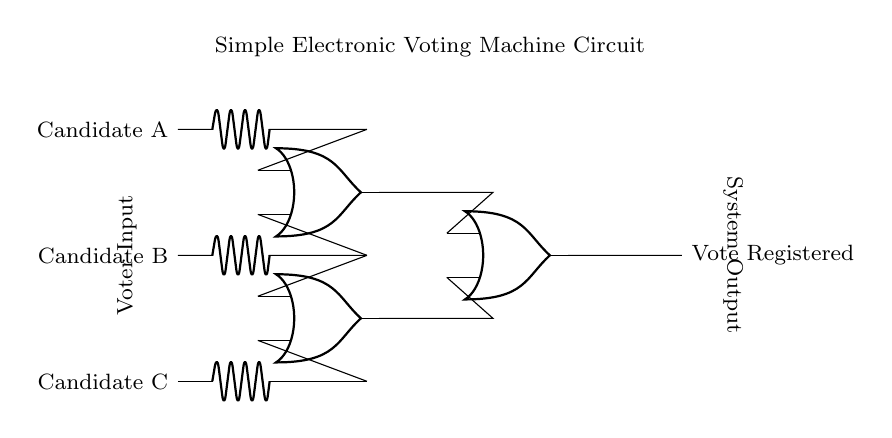What is the output of the circuit when Candidate A votes? The circuit is designed with OR gates, so if Candidate A votes, the corresponding input will be activated, leading to a registered vote.
Answer: Vote Registered What types of gates are used in this circuit? The circuit consists of OR gates, which are indicated by the symbols within the diagram. Each gate takes multiple inputs and produces a single output based on its logic.
Answer: OR gates How many candidates can be voted for in this circuit? There are three candidate inputs labeled Candidate A, B, and C, showing that the circuit can accommodate three votes.
Answer: Three What happens to the output if all candidates vote? Since all inputs are activated, the output from the OR gates will also be activated, resulting in a registered vote. In OR logic, if at least one input is high, the output is high.
Answer: Vote Registered What is the function of an OR gate in this context? The OR gate in this voting machine context functions to register a vote if at least one of its inputs is activated. If any candidate is chosen, it sends a signal through the output.
Answer: Register vote What are the labeled nodes at the left of the circuit? The labeled nodes A, B, and C on the left represent the candidates for voting, indicating the inputs to the circuit from voters.
Answer: Candidate A, B, C What does the node labelled "Vote Registered" indicate? The "Vote Registered" node indicates the output of the voting circuit, showing that a vote has been successfully counted when any of the input buttons are pressed.
Answer: Vote Registered 